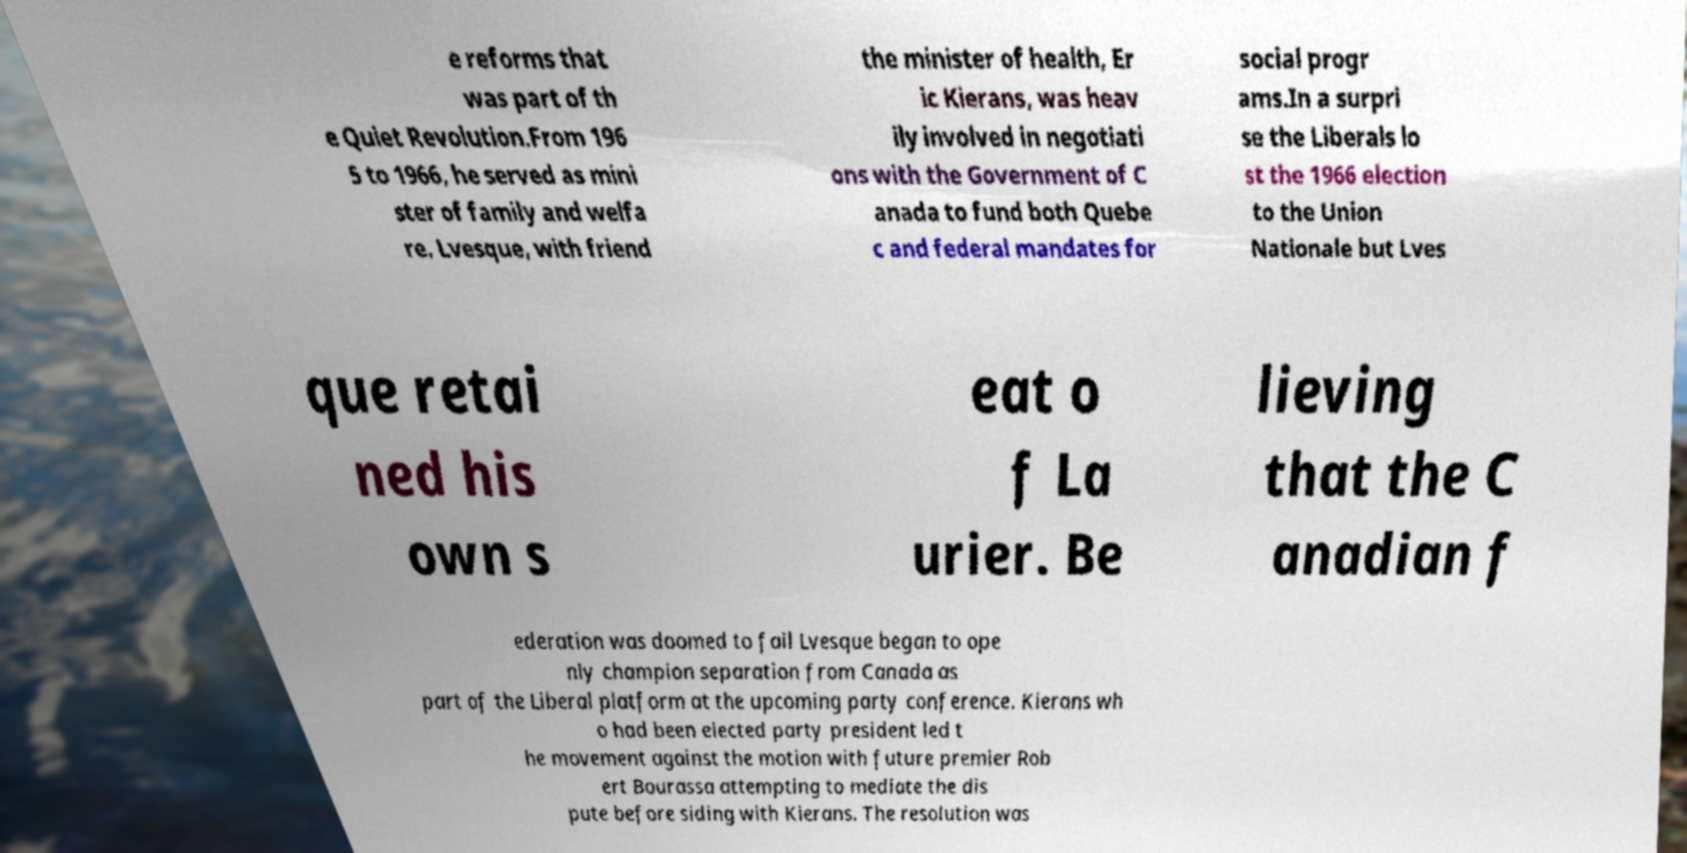Could you extract and type out the text from this image? e reforms that was part of th e Quiet Revolution.From 196 5 to 1966, he served as mini ster of family and welfa re. Lvesque, with friend the minister of health, Er ic Kierans, was heav ily involved in negotiati ons with the Government of C anada to fund both Quebe c and federal mandates for social progr ams.In a surpri se the Liberals lo st the 1966 election to the Union Nationale but Lves que retai ned his own s eat o f La urier. Be lieving that the C anadian f ederation was doomed to fail Lvesque began to ope nly champion separation from Canada as part of the Liberal platform at the upcoming party conference. Kierans wh o had been elected party president led t he movement against the motion with future premier Rob ert Bourassa attempting to mediate the dis pute before siding with Kierans. The resolution was 